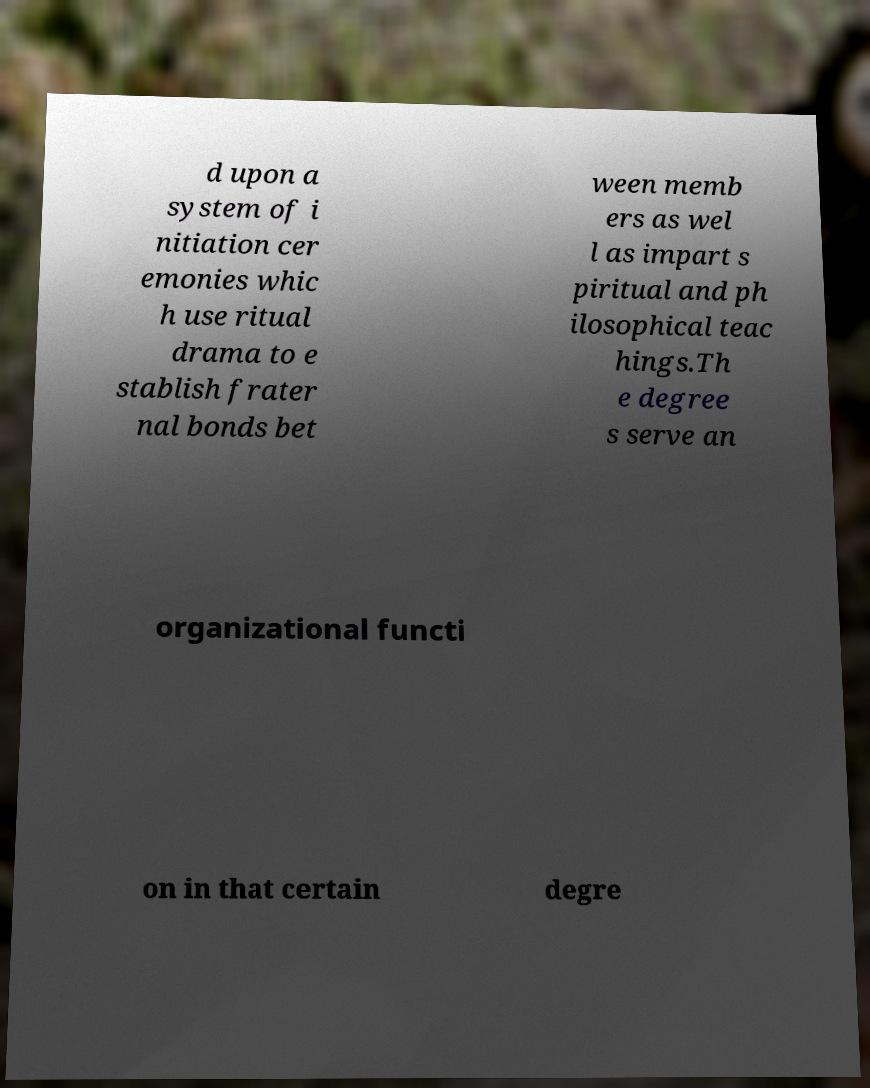What messages or text are displayed in this image? I need them in a readable, typed format. d upon a system of i nitiation cer emonies whic h use ritual drama to e stablish frater nal bonds bet ween memb ers as wel l as impart s piritual and ph ilosophical teac hings.Th e degree s serve an organizational functi on in that certain degre 